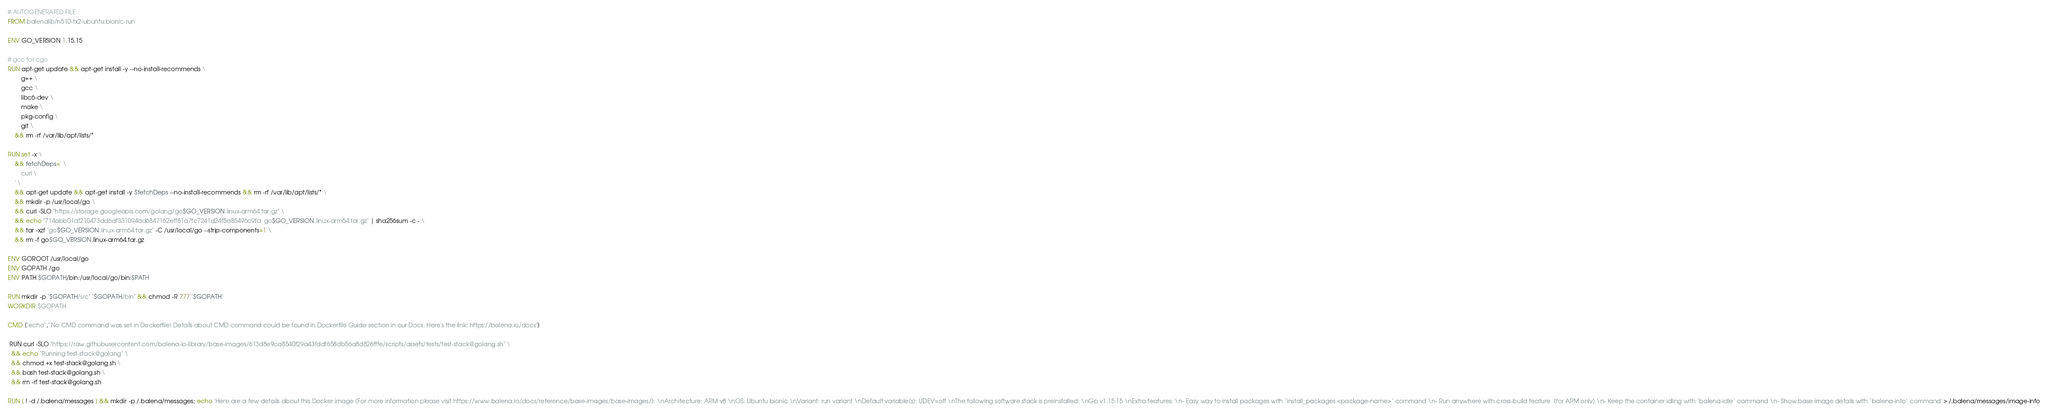Convert code to text. <code><loc_0><loc_0><loc_500><loc_500><_Dockerfile_># AUTOGENERATED FILE
FROM balenalib/n510-tx2-ubuntu:bionic-run

ENV GO_VERSION 1.15.15

# gcc for cgo
RUN apt-get update && apt-get install -y --no-install-recommends \
		g++ \
		gcc \
		libc6-dev \
		make \
		pkg-config \
		git \
	&& rm -rf /var/lib/apt/lists/*

RUN set -x \
	&& fetchDeps=' \
		curl \
	' \
	&& apt-get update && apt-get install -y $fetchDeps --no-install-recommends && rm -rf /var/lib/apt/lists/* \
	&& mkdir -p /usr/local/go \
	&& curl -SLO "https://storage.googleapis.com/golang/go$GO_VERSION.linux-arm64.tar.gz" \
	&& echo "714abb01af210473dd6af331094ad6847162eff81a7fc7241d24f5a85496c9fa  go$GO_VERSION.linux-arm64.tar.gz" | sha256sum -c - \
	&& tar -xzf "go$GO_VERSION.linux-arm64.tar.gz" -C /usr/local/go --strip-components=1 \
	&& rm -f go$GO_VERSION.linux-arm64.tar.gz

ENV GOROOT /usr/local/go
ENV GOPATH /go
ENV PATH $GOPATH/bin:/usr/local/go/bin:$PATH

RUN mkdir -p "$GOPATH/src" "$GOPATH/bin" && chmod -R 777 "$GOPATH"
WORKDIR $GOPATH

CMD ["echo","'No CMD command was set in Dockerfile! Details about CMD command could be found in Dockerfile Guide section in our Docs. Here's the link: https://balena.io/docs"]

 RUN curl -SLO "https://raw.githubusercontent.com/balena-io-library/base-images/613d8e9ca8540f29a43fddf658db56a8d826fffe/scripts/assets/tests/test-stack@golang.sh" \
  && echo "Running test-stack@golang" \
  && chmod +x test-stack@golang.sh \
  && bash test-stack@golang.sh \
  && rm -rf test-stack@golang.sh 

RUN [ ! -d /.balena/messages ] && mkdir -p /.balena/messages; echo 'Here are a few details about this Docker image (For more information please visit https://www.balena.io/docs/reference/base-images/base-images/): \nArchitecture: ARM v8 \nOS: Ubuntu bionic \nVariant: run variant \nDefault variable(s): UDEV=off \nThe following software stack is preinstalled: \nGo v1.15.15 \nExtra features: \n- Easy way to install packages with `install_packages <package-name>` command \n- Run anywhere with cross-build feature  (for ARM only) \n- Keep the container idling with `balena-idle` command \n- Show base image details with `balena-info` command' > /.balena/messages/image-info
</code> 